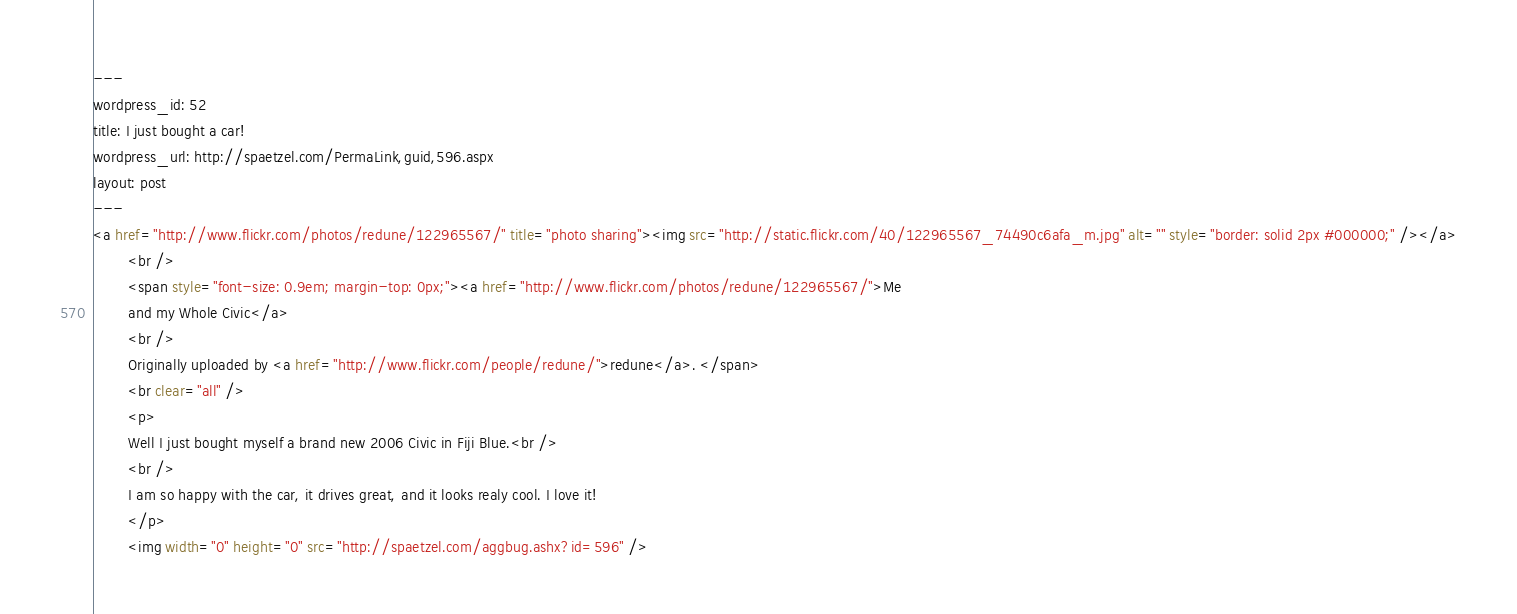Convert code to text. <code><loc_0><loc_0><loc_500><loc_500><_HTML_>--- 
wordpress_id: 52
title: I just bought a car!
wordpress_url: http://spaetzel.com/PermaLink,guid,596.aspx
layout: post
---
<a href="http://www.flickr.com/photos/redune/122965567/" title="photo sharing"><img src="http://static.flickr.com/40/122965567_74490c6afa_m.jpg" alt="" style="border: solid 2px #000000;" /></a>
        <br />
        <span style="font-size: 0.9em; margin-top: 0px;"><a href="http://www.flickr.com/photos/redune/122965567/">Me
        and my Whole Civic</a>
        <br />
        Originally uploaded by <a href="http://www.flickr.com/people/redune/">redune</a>. </span>
        <br clear="all" />
        <p>
        Well I just bought myself a brand new 2006 Civic in Fiji Blue.<br />
        <br />
        I am so happy with the car, it drives great, and it looks realy cool. I love it!
        </p>
        <img width="0" height="0" src="http://spaetzel.com/aggbug.ashx?id=596" />
</code> 